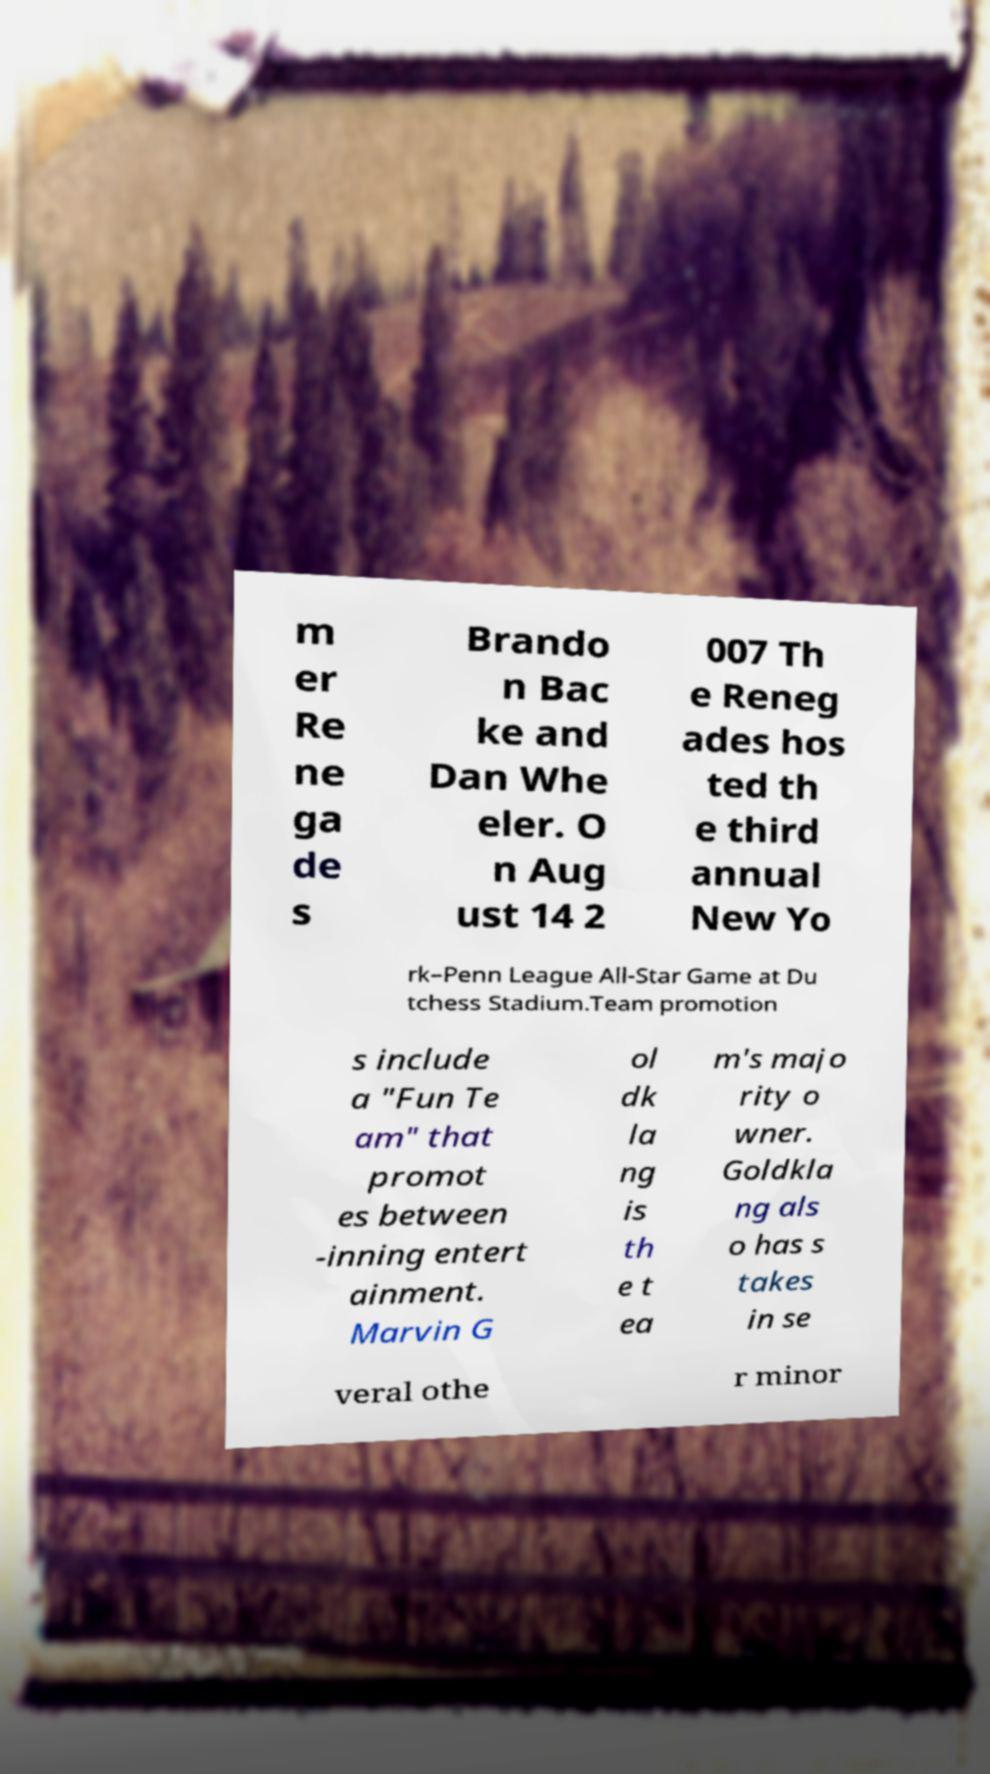There's text embedded in this image that I need extracted. Can you transcribe it verbatim? m er Re ne ga de s Brando n Bac ke and Dan Whe eler. O n Aug ust 14 2 007 Th e Reneg ades hos ted th e third annual New Yo rk–Penn League All-Star Game at Du tchess Stadium.Team promotion s include a "Fun Te am" that promot es between -inning entert ainment. Marvin G ol dk la ng is th e t ea m's majo rity o wner. Goldkla ng als o has s takes in se veral othe r minor 